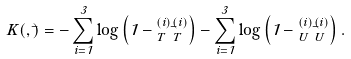Convert formula to latex. <formula><loc_0><loc_0><loc_500><loc_500>K ( \Phi , { \bar { \Phi } } ) = - \sum ^ { 3 } _ { i = 1 } \log \left ( 1 - \Phi ^ { ( i ) } _ { T } { \bar { \Phi } } ^ { ( i ) } _ { T } \right ) - \sum ^ { 3 } _ { i = 1 } \log \left ( 1 - \Phi ^ { ( i ) } _ { U } { \bar { \Phi } } ^ { ( i ) } _ { U } \right ) .</formula> 